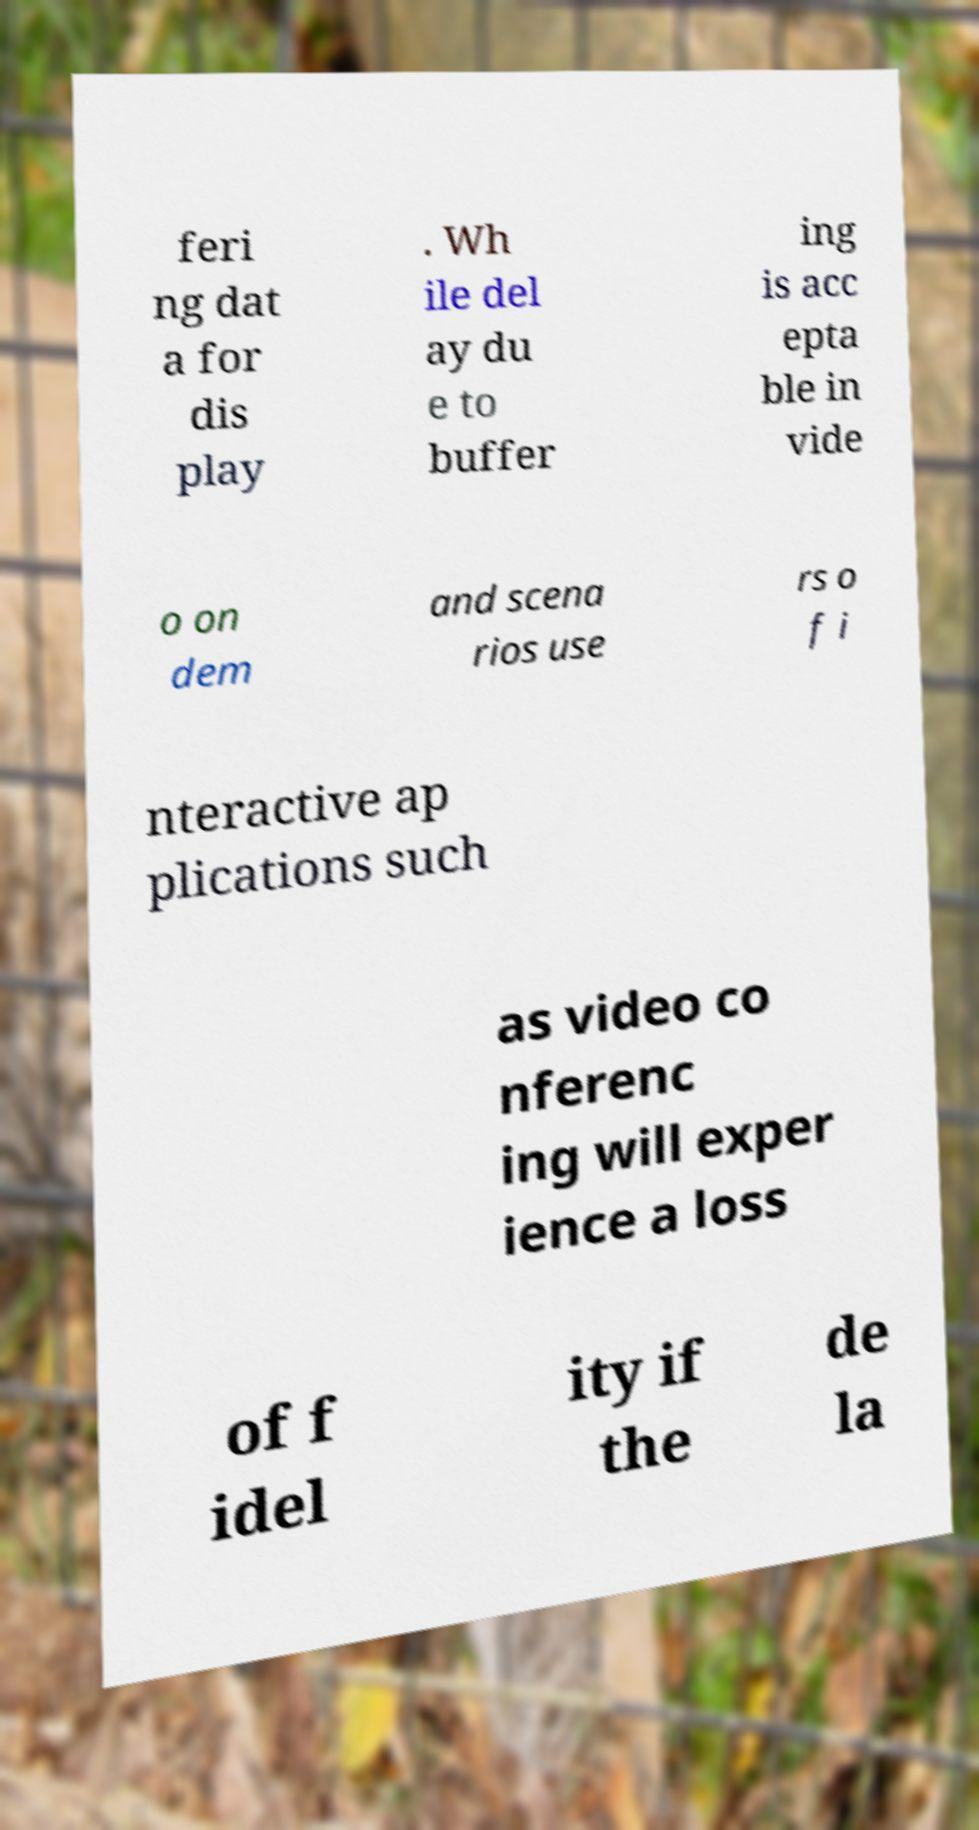Could you assist in decoding the text presented in this image and type it out clearly? feri ng dat a for dis play . Wh ile del ay du e to buffer ing is acc epta ble in vide o on dem and scena rios use rs o f i nteractive ap plications such as video co nferenc ing will exper ience a loss of f idel ity if the de la 